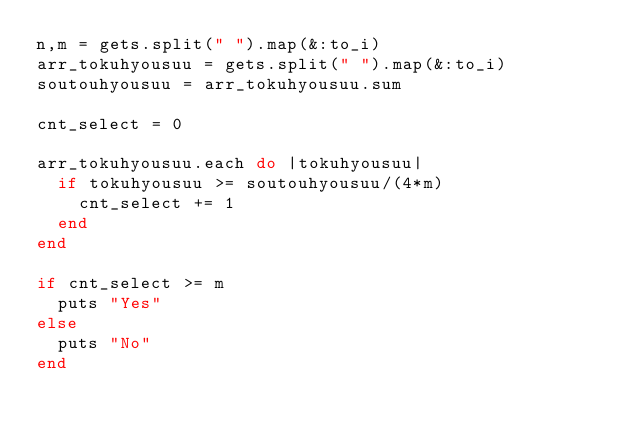<code> <loc_0><loc_0><loc_500><loc_500><_Ruby_>n,m = gets.split(" ").map(&:to_i)
arr_tokuhyousuu = gets.split(" ").map(&:to_i)
soutouhyousuu = arr_tokuhyousuu.sum

cnt_select = 0

arr_tokuhyousuu.each do |tokuhyousuu|
  if tokuhyousuu >= soutouhyousuu/(4*m)
    cnt_select += 1
  end
end

if cnt_select >= m
  puts "Yes"
else
  puts "No"
end</code> 